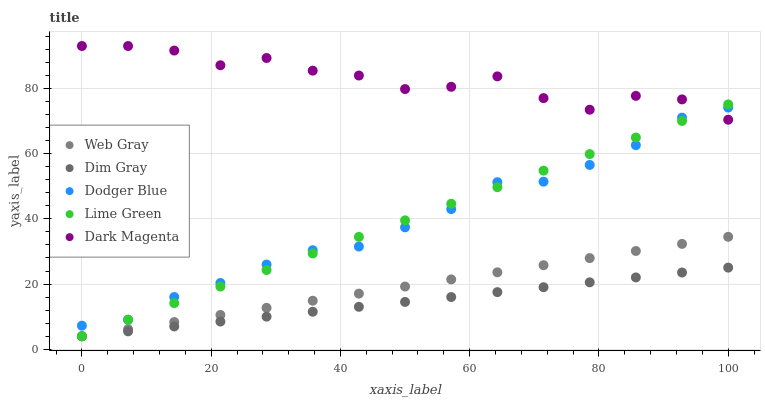Does Dim Gray have the minimum area under the curve?
Answer yes or no. Yes. Does Dark Magenta have the maximum area under the curve?
Answer yes or no. Yes. Does Web Gray have the minimum area under the curve?
Answer yes or no. No. Does Web Gray have the maximum area under the curve?
Answer yes or no. No. Is Dim Gray the smoothest?
Answer yes or no. Yes. Is Dark Magenta the roughest?
Answer yes or no. Yes. Is Web Gray the smoothest?
Answer yes or no. No. Is Web Gray the roughest?
Answer yes or no. No. Does Lime Green have the lowest value?
Answer yes or no. Yes. Does Dodger Blue have the lowest value?
Answer yes or no. No. Does Dark Magenta have the highest value?
Answer yes or no. Yes. Does Web Gray have the highest value?
Answer yes or no. No. Is Web Gray less than Dodger Blue?
Answer yes or no. Yes. Is Dodger Blue greater than Web Gray?
Answer yes or no. Yes. Does Dodger Blue intersect Dark Magenta?
Answer yes or no. Yes. Is Dodger Blue less than Dark Magenta?
Answer yes or no. No. Is Dodger Blue greater than Dark Magenta?
Answer yes or no. No. Does Web Gray intersect Dodger Blue?
Answer yes or no. No. 